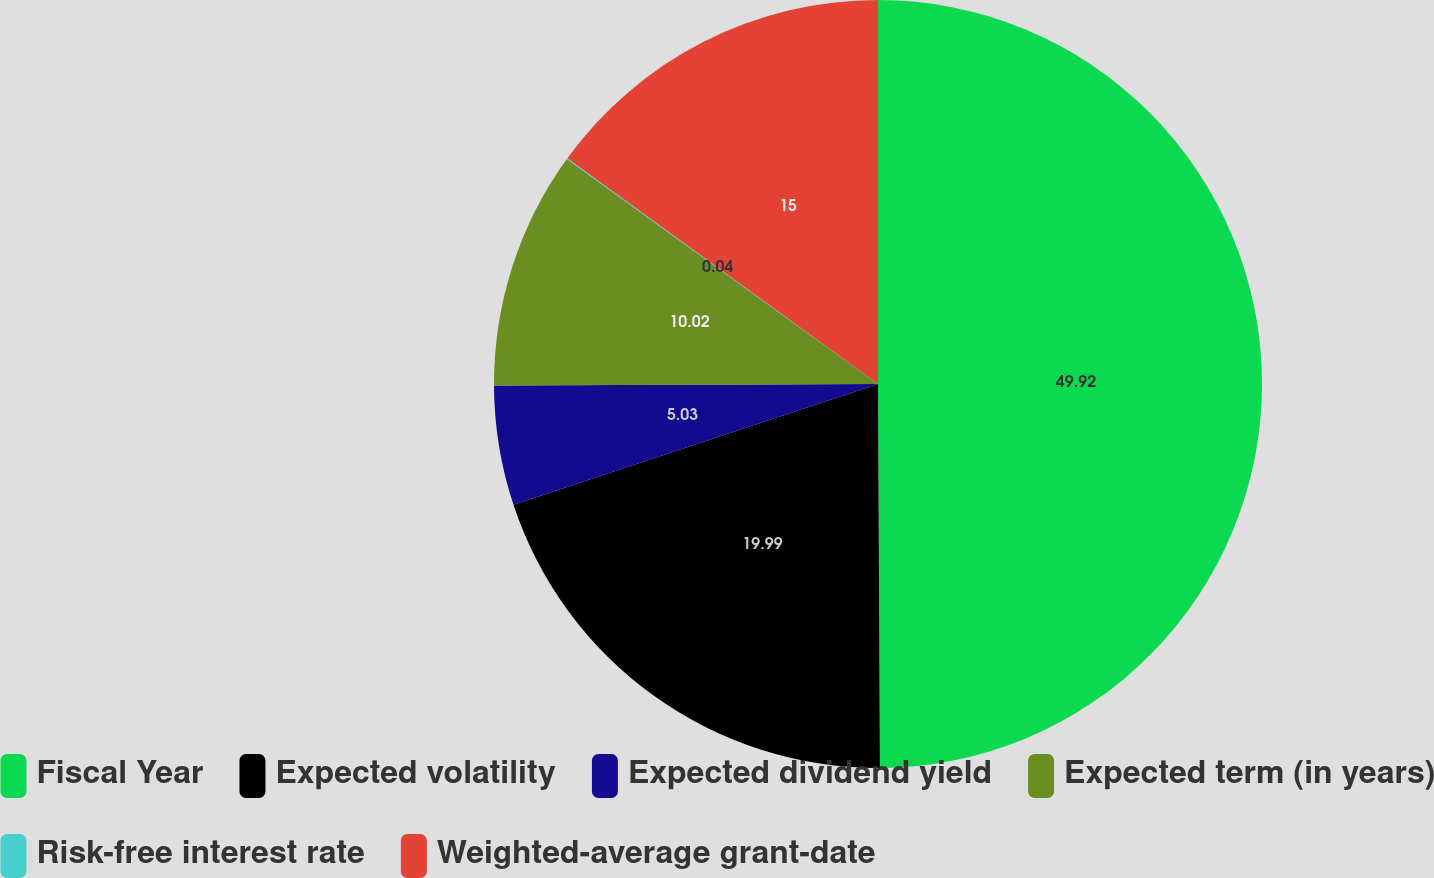Convert chart. <chart><loc_0><loc_0><loc_500><loc_500><pie_chart><fcel>Fiscal Year<fcel>Expected volatility<fcel>Expected dividend yield<fcel>Expected term (in years)<fcel>Risk-free interest rate<fcel>Weighted-average grant-date<nl><fcel>49.92%<fcel>19.99%<fcel>5.03%<fcel>10.02%<fcel>0.04%<fcel>15.0%<nl></chart> 